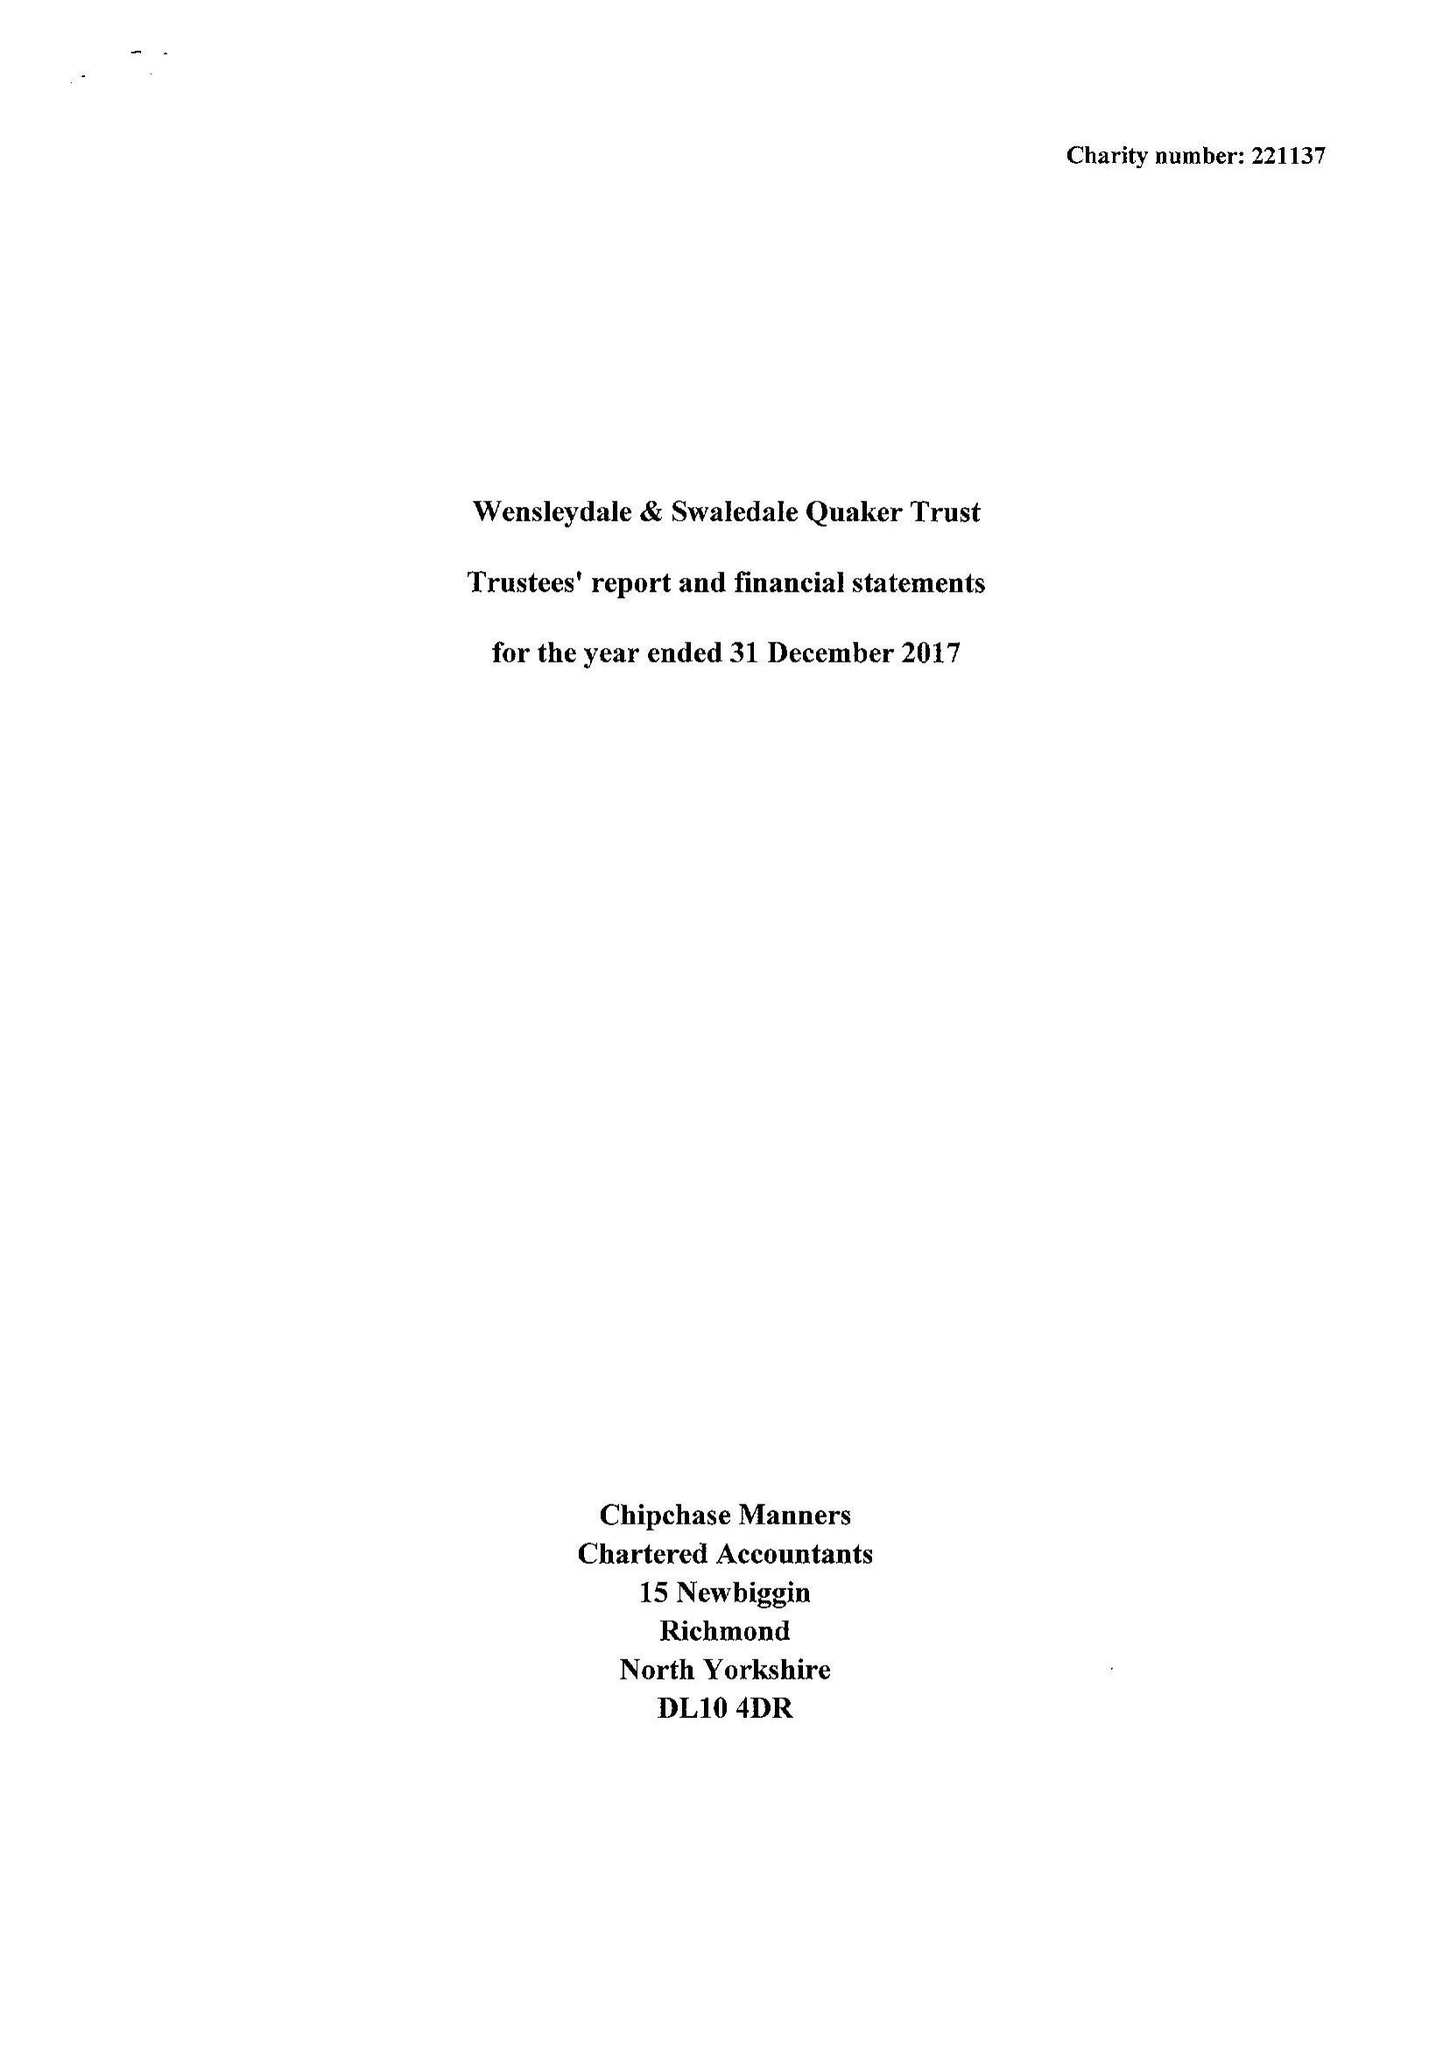What is the value for the report_date?
Answer the question using a single word or phrase. 2017-12-31 